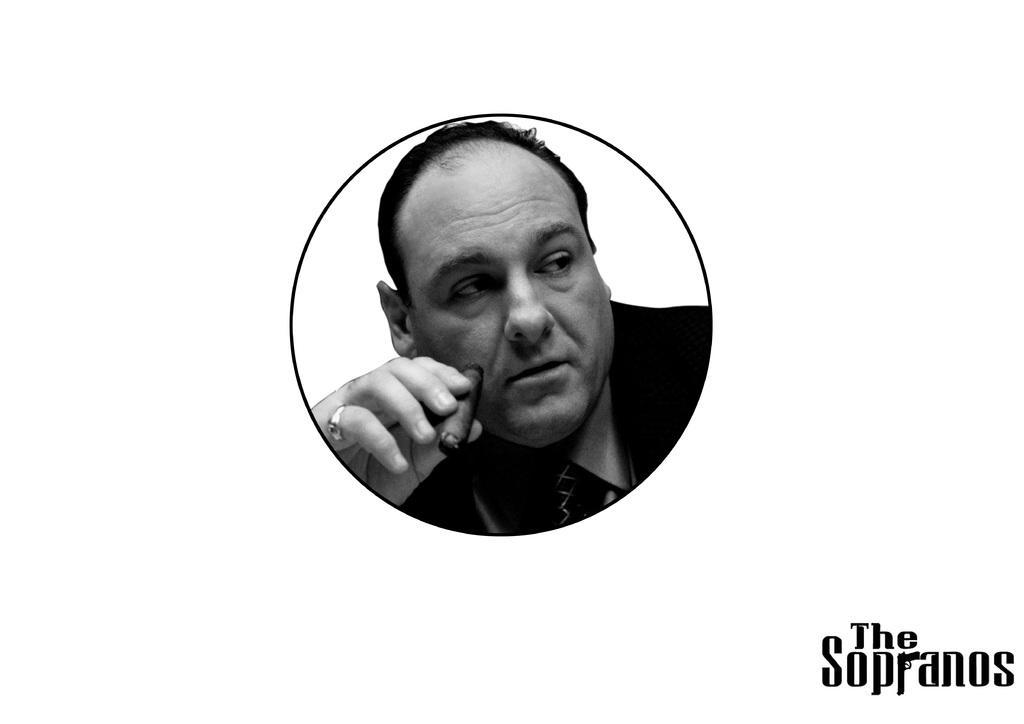What is the color scheme of the image? The image is black and white. Who is present in the image? There is a man in the image. What is the man holding in the image? The man is holding a cigar. Is there any additional information or branding on the image? Yes, there is a watermark on the image. Can you see any glasses on the table in the image? There is no table or glasses present in the image. What wish does the man make while holding the cigar in the image? The image does not depict the man making a wish, nor is there any indication of a wish being made. 